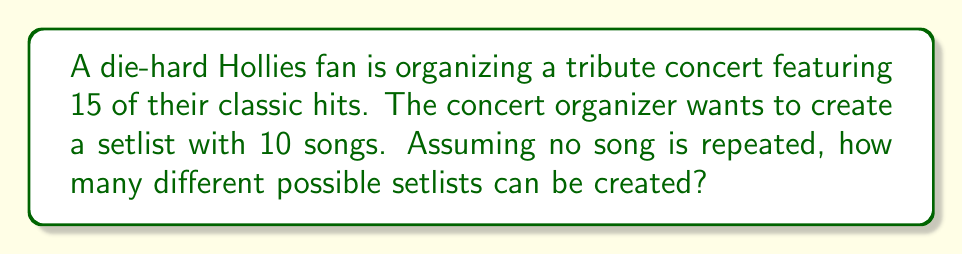Can you answer this question? Let's approach this step-by-step:

1) This is a combination problem. We're selecting 10 songs out of 15, where the order matters (as it's a setlist).

2) When the order matters and we're selecting without replacement, we use the permutation formula:

   $$P(n,r) = \frac{n!}{(n-r)!}$$

   Where $n$ is the total number of items to choose from, and $r$ is the number of items being chosen.

3) In this case, $n = 15$ (total songs) and $r = 10$ (songs in the setlist).

4) Plugging these values into the formula:

   $$P(15,10) = \frac{15!}{(15-10)!} = \frac{15!}{5!}$$

5) Expanding this:

   $$\frac{15 * 14 * 13 * 12 * 11 * 10 * 9 * 8 * 7 * 6 * 5!}{5!}$$

6) The $5!$ cancels out in the numerator and denominator:

   $$15 * 14 * 13 * 12 * 11 * 10 * 9 * 8 * 7 * 6 = 3,268,760,000$$

Therefore, there are 3,268,760,000 possible setlists.
Answer: 3,268,760,000 